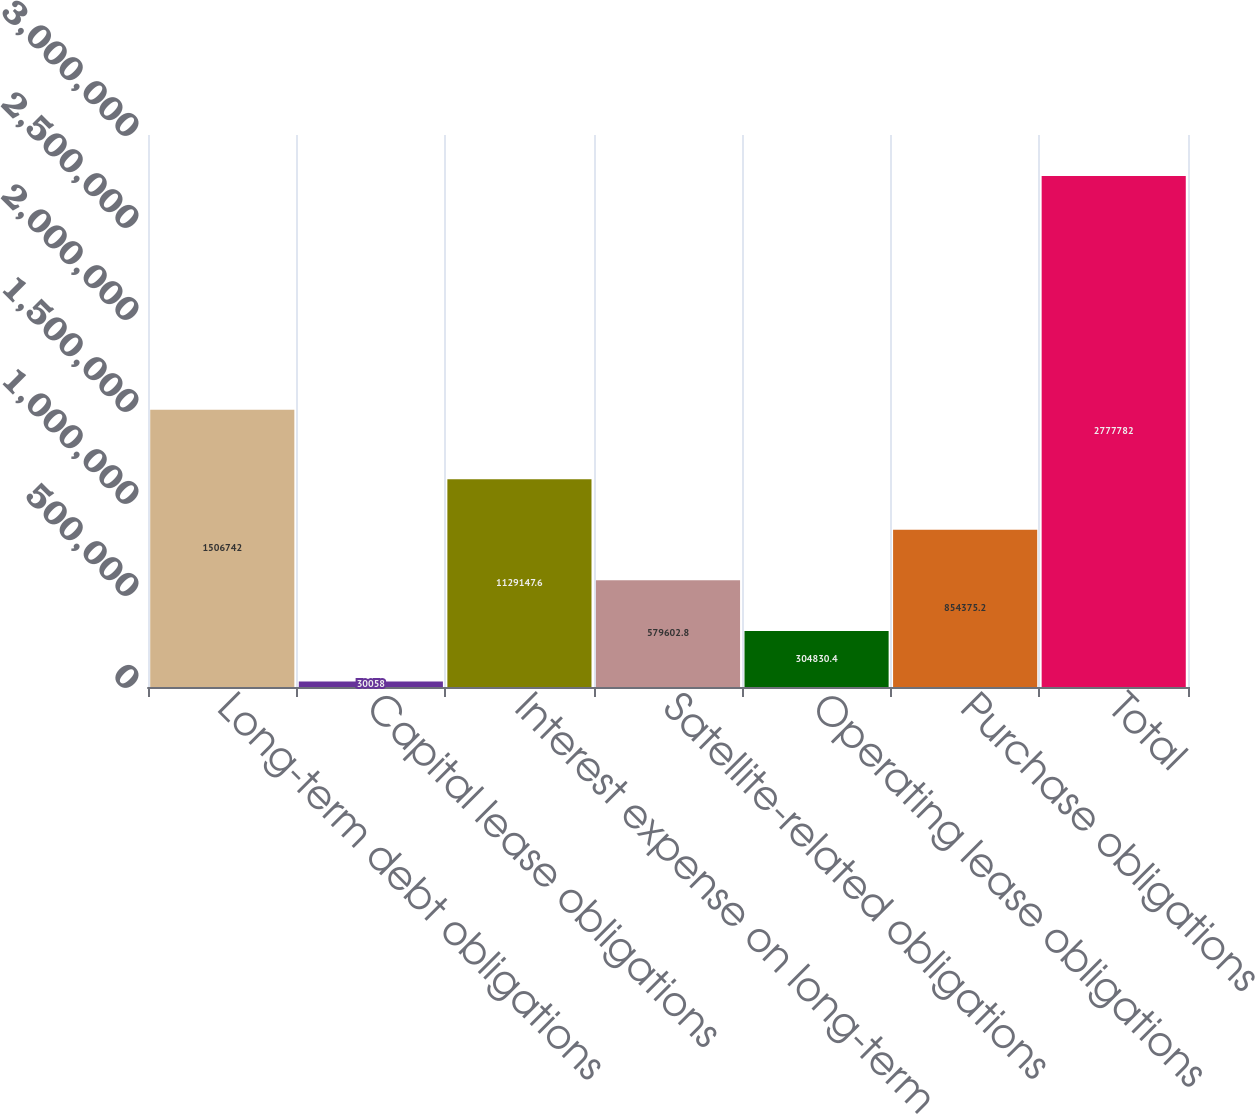Convert chart to OTSL. <chart><loc_0><loc_0><loc_500><loc_500><bar_chart><fcel>Long-term debt obligations<fcel>Capital lease obligations<fcel>Interest expense on long-term<fcel>Satellite-related obligations<fcel>Operating lease obligations<fcel>Purchase obligations<fcel>Total<nl><fcel>1.50674e+06<fcel>30058<fcel>1.12915e+06<fcel>579603<fcel>304830<fcel>854375<fcel>2.77778e+06<nl></chart> 